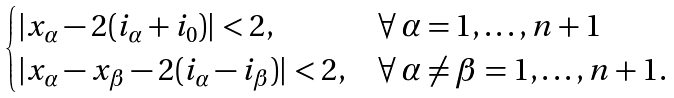Convert formula to latex. <formula><loc_0><loc_0><loc_500><loc_500>\begin{cases} | x _ { \alpha } - 2 ( i _ { \alpha } + i _ { 0 } ) | < 2 , & \forall \, \alpha = 1 , \dots , n + 1 \\ | x _ { \alpha } - x _ { \beta } - 2 ( i _ { \alpha } - i _ { \beta } ) | < 2 , & \forall \, \alpha \neq \beta = 1 , \dots , n + 1 . \end{cases}</formula> 